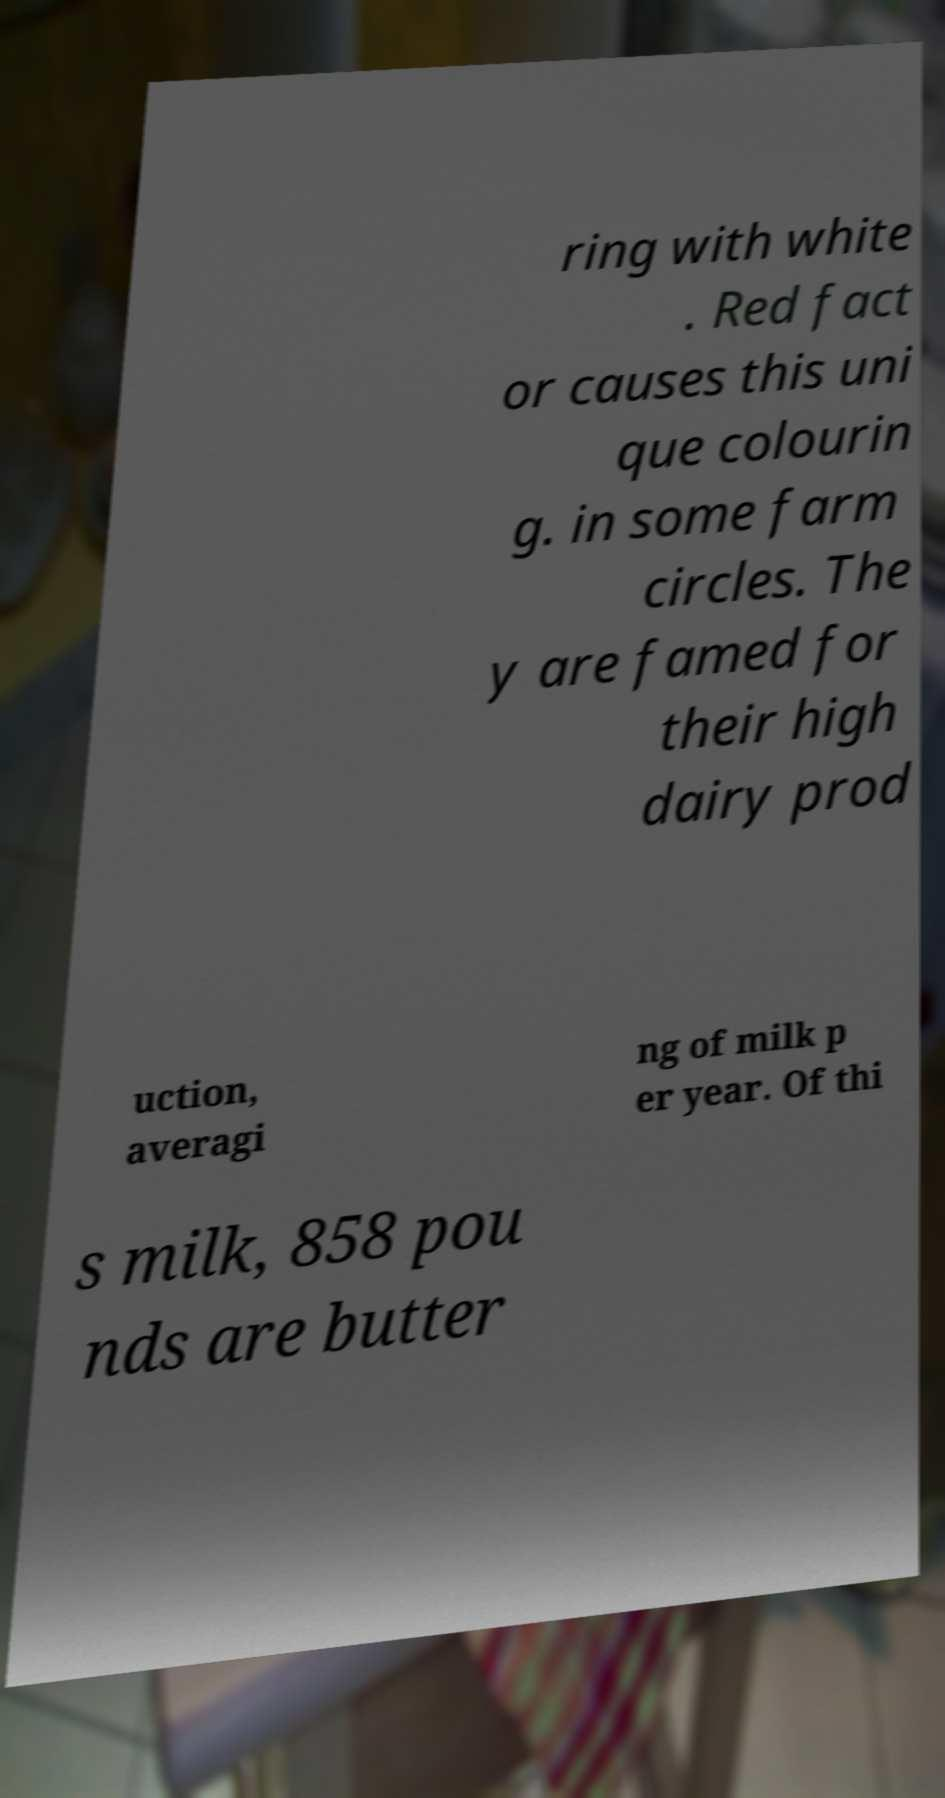Could you assist in decoding the text presented in this image and type it out clearly? ring with white . Red fact or causes this uni que colourin g. in some farm circles. The y are famed for their high dairy prod uction, averagi ng of milk p er year. Of thi s milk, 858 pou nds are butter 